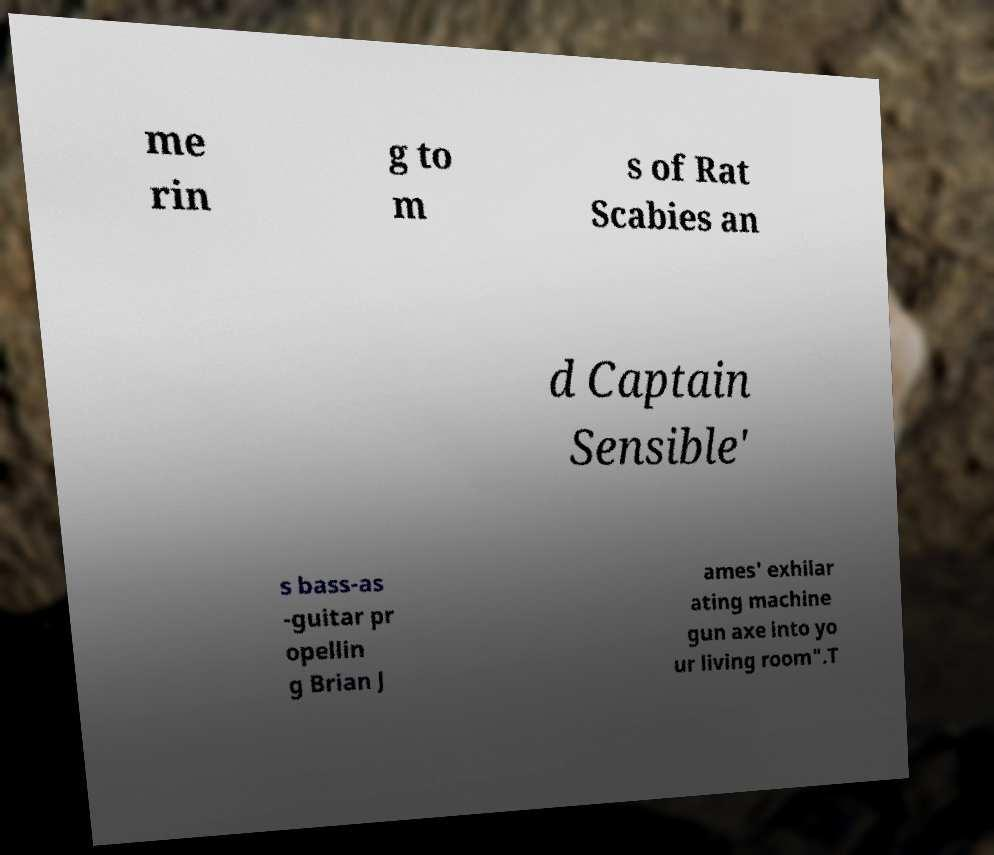Could you extract and type out the text from this image? me rin g to m s of Rat Scabies an d Captain Sensible' s bass-as -guitar pr opellin g Brian J ames' exhilar ating machine gun axe into yo ur living room".T 